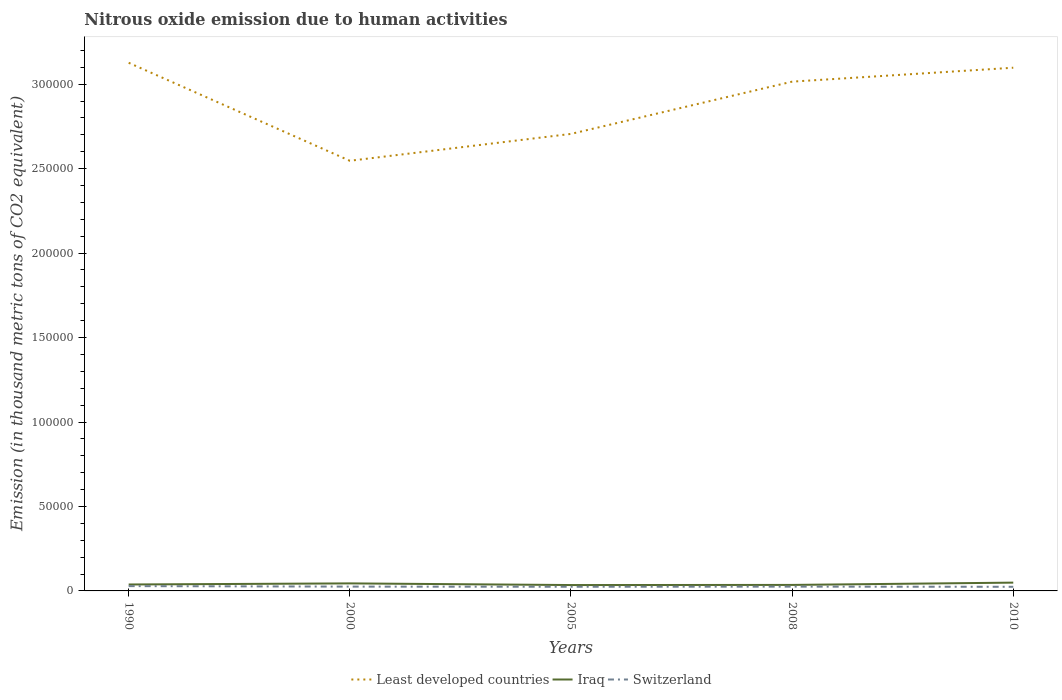How many different coloured lines are there?
Make the answer very short. 3. Is the number of lines equal to the number of legend labels?
Keep it short and to the point. Yes. Across all years, what is the maximum amount of nitrous oxide emitted in Least developed countries?
Offer a terse response. 2.55e+05. In which year was the amount of nitrous oxide emitted in Least developed countries maximum?
Offer a terse response. 2000. What is the total amount of nitrous oxide emitted in Least developed countries in the graph?
Offer a very short reply. 2927.7. What is the difference between the highest and the second highest amount of nitrous oxide emitted in Iraq?
Your response must be concise. 1430.6. What is the difference between the highest and the lowest amount of nitrous oxide emitted in Iraq?
Your answer should be compact. 2. How many lines are there?
Your response must be concise. 3. What is the difference between two consecutive major ticks on the Y-axis?
Ensure brevity in your answer.  5.00e+04. Are the values on the major ticks of Y-axis written in scientific E-notation?
Make the answer very short. No. Does the graph contain any zero values?
Offer a terse response. No. Does the graph contain grids?
Offer a terse response. No. Where does the legend appear in the graph?
Ensure brevity in your answer.  Bottom center. How many legend labels are there?
Your response must be concise. 3. How are the legend labels stacked?
Ensure brevity in your answer.  Horizontal. What is the title of the graph?
Provide a short and direct response. Nitrous oxide emission due to human activities. Does "West Bank and Gaza" appear as one of the legend labels in the graph?
Offer a terse response. No. What is the label or title of the X-axis?
Your response must be concise. Years. What is the label or title of the Y-axis?
Your answer should be very brief. Emission (in thousand metric tons of CO2 equivalent). What is the Emission (in thousand metric tons of CO2 equivalent) of Least developed countries in 1990?
Offer a terse response. 3.13e+05. What is the Emission (in thousand metric tons of CO2 equivalent) in Iraq in 1990?
Your answer should be very brief. 3808.9. What is the Emission (in thousand metric tons of CO2 equivalent) of Switzerland in 1990?
Give a very brief answer. 2846.4. What is the Emission (in thousand metric tons of CO2 equivalent) of Least developed countries in 2000?
Offer a terse response. 2.55e+05. What is the Emission (in thousand metric tons of CO2 equivalent) of Iraq in 2000?
Ensure brevity in your answer.  4462.3. What is the Emission (in thousand metric tons of CO2 equivalent) in Switzerland in 2000?
Provide a short and direct response. 2551.9. What is the Emission (in thousand metric tons of CO2 equivalent) of Least developed countries in 2005?
Your answer should be compact. 2.71e+05. What is the Emission (in thousand metric tons of CO2 equivalent) in Iraq in 2005?
Make the answer very short. 3478.3. What is the Emission (in thousand metric tons of CO2 equivalent) in Switzerland in 2005?
Provide a succinct answer. 2463.6. What is the Emission (in thousand metric tons of CO2 equivalent) in Least developed countries in 2008?
Provide a succinct answer. 3.02e+05. What is the Emission (in thousand metric tons of CO2 equivalent) in Iraq in 2008?
Provide a succinct answer. 3553.4. What is the Emission (in thousand metric tons of CO2 equivalent) of Switzerland in 2008?
Offer a terse response. 2540.6. What is the Emission (in thousand metric tons of CO2 equivalent) in Least developed countries in 2010?
Offer a very short reply. 3.10e+05. What is the Emission (in thousand metric tons of CO2 equivalent) of Iraq in 2010?
Ensure brevity in your answer.  4908.9. What is the Emission (in thousand metric tons of CO2 equivalent) in Switzerland in 2010?
Ensure brevity in your answer.  2441.9. Across all years, what is the maximum Emission (in thousand metric tons of CO2 equivalent) in Least developed countries?
Offer a very short reply. 3.13e+05. Across all years, what is the maximum Emission (in thousand metric tons of CO2 equivalent) of Iraq?
Offer a terse response. 4908.9. Across all years, what is the maximum Emission (in thousand metric tons of CO2 equivalent) in Switzerland?
Provide a short and direct response. 2846.4. Across all years, what is the minimum Emission (in thousand metric tons of CO2 equivalent) of Least developed countries?
Your answer should be compact. 2.55e+05. Across all years, what is the minimum Emission (in thousand metric tons of CO2 equivalent) of Iraq?
Ensure brevity in your answer.  3478.3. Across all years, what is the minimum Emission (in thousand metric tons of CO2 equivalent) of Switzerland?
Your answer should be compact. 2441.9. What is the total Emission (in thousand metric tons of CO2 equivalent) in Least developed countries in the graph?
Provide a succinct answer. 1.45e+06. What is the total Emission (in thousand metric tons of CO2 equivalent) of Iraq in the graph?
Ensure brevity in your answer.  2.02e+04. What is the total Emission (in thousand metric tons of CO2 equivalent) in Switzerland in the graph?
Provide a short and direct response. 1.28e+04. What is the difference between the Emission (in thousand metric tons of CO2 equivalent) of Least developed countries in 1990 and that in 2000?
Provide a succinct answer. 5.80e+04. What is the difference between the Emission (in thousand metric tons of CO2 equivalent) in Iraq in 1990 and that in 2000?
Your response must be concise. -653.4. What is the difference between the Emission (in thousand metric tons of CO2 equivalent) in Switzerland in 1990 and that in 2000?
Give a very brief answer. 294.5. What is the difference between the Emission (in thousand metric tons of CO2 equivalent) of Least developed countries in 1990 and that in 2005?
Give a very brief answer. 4.21e+04. What is the difference between the Emission (in thousand metric tons of CO2 equivalent) in Iraq in 1990 and that in 2005?
Offer a terse response. 330.6. What is the difference between the Emission (in thousand metric tons of CO2 equivalent) in Switzerland in 1990 and that in 2005?
Provide a succinct answer. 382.8. What is the difference between the Emission (in thousand metric tons of CO2 equivalent) of Least developed countries in 1990 and that in 2008?
Give a very brief answer. 1.12e+04. What is the difference between the Emission (in thousand metric tons of CO2 equivalent) of Iraq in 1990 and that in 2008?
Your answer should be very brief. 255.5. What is the difference between the Emission (in thousand metric tons of CO2 equivalent) of Switzerland in 1990 and that in 2008?
Give a very brief answer. 305.8. What is the difference between the Emission (in thousand metric tons of CO2 equivalent) in Least developed countries in 1990 and that in 2010?
Make the answer very short. 2927.7. What is the difference between the Emission (in thousand metric tons of CO2 equivalent) in Iraq in 1990 and that in 2010?
Offer a very short reply. -1100. What is the difference between the Emission (in thousand metric tons of CO2 equivalent) of Switzerland in 1990 and that in 2010?
Ensure brevity in your answer.  404.5. What is the difference between the Emission (in thousand metric tons of CO2 equivalent) of Least developed countries in 2000 and that in 2005?
Your response must be concise. -1.59e+04. What is the difference between the Emission (in thousand metric tons of CO2 equivalent) of Iraq in 2000 and that in 2005?
Give a very brief answer. 984. What is the difference between the Emission (in thousand metric tons of CO2 equivalent) in Switzerland in 2000 and that in 2005?
Ensure brevity in your answer.  88.3. What is the difference between the Emission (in thousand metric tons of CO2 equivalent) in Least developed countries in 2000 and that in 2008?
Offer a terse response. -4.69e+04. What is the difference between the Emission (in thousand metric tons of CO2 equivalent) of Iraq in 2000 and that in 2008?
Keep it short and to the point. 908.9. What is the difference between the Emission (in thousand metric tons of CO2 equivalent) in Switzerland in 2000 and that in 2008?
Offer a very short reply. 11.3. What is the difference between the Emission (in thousand metric tons of CO2 equivalent) in Least developed countries in 2000 and that in 2010?
Make the answer very short. -5.51e+04. What is the difference between the Emission (in thousand metric tons of CO2 equivalent) of Iraq in 2000 and that in 2010?
Offer a very short reply. -446.6. What is the difference between the Emission (in thousand metric tons of CO2 equivalent) in Switzerland in 2000 and that in 2010?
Make the answer very short. 110. What is the difference between the Emission (in thousand metric tons of CO2 equivalent) in Least developed countries in 2005 and that in 2008?
Keep it short and to the point. -3.09e+04. What is the difference between the Emission (in thousand metric tons of CO2 equivalent) in Iraq in 2005 and that in 2008?
Provide a succinct answer. -75.1. What is the difference between the Emission (in thousand metric tons of CO2 equivalent) of Switzerland in 2005 and that in 2008?
Provide a succinct answer. -77. What is the difference between the Emission (in thousand metric tons of CO2 equivalent) of Least developed countries in 2005 and that in 2010?
Your answer should be compact. -3.92e+04. What is the difference between the Emission (in thousand metric tons of CO2 equivalent) in Iraq in 2005 and that in 2010?
Your response must be concise. -1430.6. What is the difference between the Emission (in thousand metric tons of CO2 equivalent) in Switzerland in 2005 and that in 2010?
Your answer should be compact. 21.7. What is the difference between the Emission (in thousand metric tons of CO2 equivalent) in Least developed countries in 2008 and that in 2010?
Give a very brief answer. -8239.1. What is the difference between the Emission (in thousand metric tons of CO2 equivalent) of Iraq in 2008 and that in 2010?
Offer a very short reply. -1355.5. What is the difference between the Emission (in thousand metric tons of CO2 equivalent) of Switzerland in 2008 and that in 2010?
Give a very brief answer. 98.7. What is the difference between the Emission (in thousand metric tons of CO2 equivalent) in Least developed countries in 1990 and the Emission (in thousand metric tons of CO2 equivalent) in Iraq in 2000?
Your response must be concise. 3.08e+05. What is the difference between the Emission (in thousand metric tons of CO2 equivalent) of Least developed countries in 1990 and the Emission (in thousand metric tons of CO2 equivalent) of Switzerland in 2000?
Offer a terse response. 3.10e+05. What is the difference between the Emission (in thousand metric tons of CO2 equivalent) in Iraq in 1990 and the Emission (in thousand metric tons of CO2 equivalent) in Switzerland in 2000?
Offer a terse response. 1257. What is the difference between the Emission (in thousand metric tons of CO2 equivalent) in Least developed countries in 1990 and the Emission (in thousand metric tons of CO2 equivalent) in Iraq in 2005?
Make the answer very short. 3.09e+05. What is the difference between the Emission (in thousand metric tons of CO2 equivalent) in Least developed countries in 1990 and the Emission (in thousand metric tons of CO2 equivalent) in Switzerland in 2005?
Give a very brief answer. 3.10e+05. What is the difference between the Emission (in thousand metric tons of CO2 equivalent) in Iraq in 1990 and the Emission (in thousand metric tons of CO2 equivalent) in Switzerland in 2005?
Your answer should be very brief. 1345.3. What is the difference between the Emission (in thousand metric tons of CO2 equivalent) of Least developed countries in 1990 and the Emission (in thousand metric tons of CO2 equivalent) of Iraq in 2008?
Provide a short and direct response. 3.09e+05. What is the difference between the Emission (in thousand metric tons of CO2 equivalent) in Least developed countries in 1990 and the Emission (in thousand metric tons of CO2 equivalent) in Switzerland in 2008?
Give a very brief answer. 3.10e+05. What is the difference between the Emission (in thousand metric tons of CO2 equivalent) in Iraq in 1990 and the Emission (in thousand metric tons of CO2 equivalent) in Switzerland in 2008?
Make the answer very short. 1268.3. What is the difference between the Emission (in thousand metric tons of CO2 equivalent) in Least developed countries in 1990 and the Emission (in thousand metric tons of CO2 equivalent) in Iraq in 2010?
Give a very brief answer. 3.08e+05. What is the difference between the Emission (in thousand metric tons of CO2 equivalent) of Least developed countries in 1990 and the Emission (in thousand metric tons of CO2 equivalent) of Switzerland in 2010?
Provide a short and direct response. 3.10e+05. What is the difference between the Emission (in thousand metric tons of CO2 equivalent) in Iraq in 1990 and the Emission (in thousand metric tons of CO2 equivalent) in Switzerland in 2010?
Your response must be concise. 1367. What is the difference between the Emission (in thousand metric tons of CO2 equivalent) in Least developed countries in 2000 and the Emission (in thousand metric tons of CO2 equivalent) in Iraq in 2005?
Your answer should be very brief. 2.51e+05. What is the difference between the Emission (in thousand metric tons of CO2 equivalent) in Least developed countries in 2000 and the Emission (in thousand metric tons of CO2 equivalent) in Switzerland in 2005?
Your answer should be very brief. 2.52e+05. What is the difference between the Emission (in thousand metric tons of CO2 equivalent) of Iraq in 2000 and the Emission (in thousand metric tons of CO2 equivalent) of Switzerland in 2005?
Give a very brief answer. 1998.7. What is the difference between the Emission (in thousand metric tons of CO2 equivalent) of Least developed countries in 2000 and the Emission (in thousand metric tons of CO2 equivalent) of Iraq in 2008?
Provide a succinct answer. 2.51e+05. What is the difference between the Emission (in thousand metric tons of CO2 equivalent) in Least developed countries in 2000 and the Emission (in thousand metric tons of CO2 equivalent) in Switzerland in 2008?
Provide a succinct answer. 2.52e+05. What is the difference between the Emission (in thousand metric tons of CO2 equivalent) of Iraq in 2000 and the Emission (in thousand metric tons of CO2 equivalent) of Switzerland in 2008?
Provide a succinct answer. 1921.7. What is the difference between the Emission (in thousand metric tons of CO2 equivalent) in Least developed countries in 2000 and the Emission (in thousand metric tons of CO2 equivalent) in Iraq in 2010?
Your answer should be compact. 2.50e+05. What is the difference between the Emission (in thousand metric tons of CO2 equivalent) in Least developed countries in 2000 and the Emission (in thousand metric tons of CO2 equivalent) in Switzerland in 2010?
Offer a terse response. 2.52e+05. What is the difference between the Emission (in thousand metric tons of CO2 equivalent) in Iraq in 2000 and the Emission (in thousand metric tons of CO2 equivalent) in Switzerland in 2010?
Give a very brief answer. 2020.4. What is the difference between the Emission (in thousand metric tons of CO2 equivalent) of Least developed countries in 2005 and the Emission (in thousand metric tons of CO2 equivalent) of Iraq in 2008?
Offer a terse response. 2.67e+05. What is the difference between the Emission (in thousand metric tons of CO2 equivalent) in Least developed countries in 2005 and the Emission (in thousand metric tons of CO2 equivalent) in Switzerland in 2008?
Provide a succinct answer. 2.68e+05. What is the difference between the Emission (in thousand metric tons of CO2 equivalent) in Iraq in 2005 and the Emission (in thousand metric tons of CO2 equivalent) in Switzerland in 2008?
Give a very brief answer. 937.7. What is the difference between the Emission (in thousand metric tons of CO2 equivalent) of Least developed countries in 2005 and the Emission (in thousand metric tons of CO2 equivalent) of Iraq in 2010?
Your answer should be very brief. 2.66e+05. What is the difference between the Emission (in thousand metric tons of CO2 equivalent) of Least developed countries in 2005 and the Emission (in thousand metric tons of CO2 equivalent) of Switzerland in 2010?
Your response must be concise. 2.68e+05. What is the difference between the Emission (in thousand metric tons of CO2 equivalent) in Iraq in 2005 and the Emission (in thousand metric tons of CO2 equivalent) in Switzerland in 2010?
Provide a succinct answer. 1036.4. What is the difference between the Emission (in thousand metric tons of CO2 equivalent) in Least developed countries in 2008 and the Emission (in thousand metric tons of CO2 equivalent) in Iraq in 2010?
Your answer should be very brief. 2.97e+05. What is the difference between the Emission (in thousand metric tons of CO2 equivalent) of Least developed countries in 2008 and the Emission (in thousand metric tons of CO2 equivalent) of Switzerland in 2010?
Provide a succinct answer. 2.99e+05. What is the difference between the Emission (in thousand metric tons of CO2 equivalent) of Iraq in 2008 and the Emission (in thousand metric tons of CO2 equivalent) of Switzerland in 2010?
Keep it short and to the point. 1111.5. What is the average Emission (in thousand metric tons of CO2 equivalent) of Least developed countries per year?
Give a very brief answer. 2.90e+05. What is the average Emission (in thousand metric tons of CO2 equivalent) of Iraq per year?
Make the answer very short. 4042.36. What is the average Emission (in thousand metric tons of CO2 equivalent) of Switzerland per year?
Provide a short and direct response. 2568.88. In the year 1990, what is the difference between the Emission (in thousand metric tons of CO2 equivalent) of Least developed countries and Emission (in thousand metric tons of CO2 equivalent) of Iraq?
Offer a terse response. 3.09e+05. In the year 1990, what is the difference between the Emission (in thousand metric tons of CO2 equivalent) of Least developed countries and Emission (in thousand metric tons of CO2 equivalent) of Switzerland?
Your response must be concise. 3.10e+05. In the year 1990, what is the difference between the Emission (in thousand metric tons of CO2 equivalent) in Iraq and Emission (in thousand metric tons of CO2 equivalent) in Switzerland?
Your answer should be compact. 962.5. In the year 2000, what is the difference between the Emission (in thousand metric tons of CO2 equivalent) of Least developed countries and Emission (in thousand metric tons of CO2 equivalent) of Iraq?
Your response must be concise. 2.50e+05. In the year 2000, what is the difference between the Emission (in thousand metric tons of CO2 equivalent) in Least developed countries and Emission (in thousand metric tons of CO2 equivalent) in Switzerland?
Your answer should be very brief. 2.52e+05. In the year 2000, what is the difference between the Emission (in thousand metric tons of CO2 equivalent) of Iraq and Emission (in thousand metric tons of CO2 equivalent) of Switzerland?
Provide a short and direct response. 1910.4. In the year 2005, what is the difference between the Emission (in thousand metric tons of CO2 equivalent) in Least developed countries and Emission (in thousand metric tons of CO2 equivalent) in Iraq?
Offer a terse response. 2.67e+05. In the year 2005, what is the difference between the Emission (in thousand metric tons of CO2 equivalent) of Least developed countries and Emission (in thousand metric tons of CO2 equivalent) of Switzerland?
Your response must be concise. 2.68e+05. In the year 2005, what is the difference between the Emission (in thousand metric tons of CO2 equivalent) in Iraq and Emission (in thousand metric tons of CO2 equivalent) in Switzerland?
Your answer should be very brief. 1014.7. In the year 2008, what is the difference between the Emission (in thousand metric tons of CO2 equivalent) in Least developed countries and Emission (in thousand metric tons of CO2 equivalent) in Iraq?
Offer a terse response. 2.98e+05. In the year 2008, what is the difference between the Emission (in thousand metric tons of CO2 equivalent) of Least developed countries and Emission (in thousand metric tons of CO2 equivalent) of Switzerland?
Provide a short and direct response. 2.99e+05. In the year 2008, what is the difference between the Emission (in thousand metric tons of CO2 equivalent) of Iraq and Emission (in thousand metric tons of CO2 equivalent) of Switzerland?
Keep it short and to the point. 1012.8. In the year 2010, what is the difference between the Emission (in thousand metric tons of CO2 equivalent) of Least developed countries and Emission (in thousand metric tons of CO2 equivalent) of Iraq?
Offer a very short reply. 3.05e+05. In the year 2010, what is the difference between the Emission (in thousand metric tons of CO2 equivalent) of Least developed countries and Emission (in thousand metric tons of CO2 equivalent) of Switzerland?
Provide a short and direct response. 3.07e+05. In the year 2010, what is the difference between the Emission (in thousand metric tons of CO2 equivalent) in Iraq and Emission (in thousand metric tons of CO2 equivalent) in Switzerland?
Make the answer very short. 2467. What is the ratio of the Emission (in thousand metric tons of CO2 equivalent) of Least developed countries in 1990 to that in 2000?
Your answer should be compact. 1.23. What is the ratio of the Emission (in thousand metric tons of CO2 equivalent) of Iraq in 1990 to that in 2000?
Provide a short and direct response. 0.85. What is the ratio of the Emission (in thousand metric tons of CO2 equivalent) of Switzerland in 1990 to that in 2000?
Give a very brief answer. 1.12. What is the ratio of the Emission (in thousand metric tons of CO2 equivalent) in Least developed countries in 1990 to that in 2005?
Your response must be concise. 1.16. What is the ratio of the Emission (in thousand metric tons of CO2 equivalent) of Iraq in 1990 to that in 2005?
Ensure brevity in your answer.  1.09. What is the ratio of the Emission (in thousand metric tons of CO2 equivalent) of Switzerland in 1990 to that in 2005?
Offer a terse response. 1.16. What is the ratio of the Emission (in thousand metric tons of CO2 equivalent) of Iraq in 1990 to that in 2008?
Give a very brief answer. 1.07. What is the ratio of the Emission (in thousand metric tons of CO2 equivalent) in Switzerland in 1990 to that in 2008?
Keep it short and to the point. 1.12. What is the ratio of the Emission (in thousand metric tons of CO2 equivalent) in Least developed countries in 1990 to that in 2010?
Provide a succinct answer. 1.01. What is the ratio of the Emission (in thousand metric tons of CO2 equivalent) of Iraq in 1990 to that in 2010?
Give a very brief answer. 0.78. What is the ratio of the Emission (in thousand metric tons of CO2 equivalent) of Switzerland in 1990 to that in 2010?
Provide a succinct answer. 1.17. What is the ratio of the Emission (in thousand metric tons of CO2 equivalent) of Iraq in 2000 to that in 2005?
Make the answer very short. 1.28. What is the ratio of the Emission (in thousand metric tons of CO2 equivalent) in Switzerland in 2000 to that in 2005?
Your answer should be very brief. 1.04. What is the ratio of the Emission (in thousand metric tons of CO2 equivalent) of Least developed countries in 2000 to that in 2008?
Ensure brevity in your answer.  0.84. What is the ratio of the Emission (in thousand metric tons of CO2 equivalent) in Iraq in 2000 to that in 2008?
Offer a very short reply. 1.26. What is the ratio of the Emission (in thousand metric tons of CO2 equivalent) in Least developed countries in 2000 to that in 2010?
Provide a short and direct response. 0.82. What is the ratio of the Emission (in thousand metric tons of CO2 equivalent) in Iraq in 2000 to that in 2010?
Your answer should be compact. 0.91. What is the ratio of the Emission (in thousand metric tons of CO2 equivalent) of Switzerland in 2000 to that in 2010?
Offer a very short reply. 1.04. What is the ratio of the Emission (in thousand metric tons of CO2 equivalent) in Least developed countries in 2005 to that in 2008?
Offer a very short reply. 0.9. What is the ratio of the Emission (in thousand metric tons of CO2 equivalent) in Iraq in 2005 to that in 2008?
Your answer should be very brief. 0.98. What is the ratio of the Emission (in thousand metric tons of CO2 equivalent) of Switzerland in 2005 to that in 2008?
Offer a terse response. 0.97. What is the ratio of the Emission (in thousand metric tons of CO2 equivalent) in Least developed countries in 2005 to that in 2010?
Make the answer very short. 0.87. What is the ratio of the Emission (in thousand metric tons of CO2 equivalent) in Iraq in 2005 to that in 2010?
Provide a succinct answer. 0.71. What is the ratio of the Emission (in thousand metric tons of CO2 equivalent) in Switzerland in 2005 to that in 2010?
Your answer should be very brief. 1.01. What is the ratio of the Emission (in thousand metric tons of CO2 equivalent) of Least developed countries in 2008 to that in 2010?
Your answer should be very brief. 0.97. What is the ratio of the Emission (in thousand metric tons of CO2 equivalent) of Iraq in 2008 to that in 2010?
Provide a short and direct response. 0.72. What is the ratio of the Emission (in thousand metric tons of CO2 equivalent) of Switzerland in 2008 to that in 2010?
Offer a terse response. 1.04. What is the difference between the highest and the second highest Emission (in thousand metric tons of CO2 equivalent) of Least developed countries?
Make the answer very short. 2927.7. What is the difference between the highest and the second highest Emission (in thousand metric tons of CO2 equivalent) of Iraq?
Give a very brief answer. 446.6. What is the difference between the highest and the second highest Emission (in thousand metric tons of CO2 equivalent) of Switzerland?
Keep it short and to the point. 294.5. What is the difference between the highest and the lowest Emission (in thousand metric tons of CO2 equivalent) of Least developed countries?
Keep it short and to the point. 5.80e+04. What is the difference between the highest and the lowest Emission (in thousand metric tons of CO2 equivalent) of Iraq?
Offer a terse response. 1430.6. What is the difference between the highest and the lowest Emission (in thousand metric tons of CO2 equivalent) in Switzerland?
Make the answer very short. 404.5. 